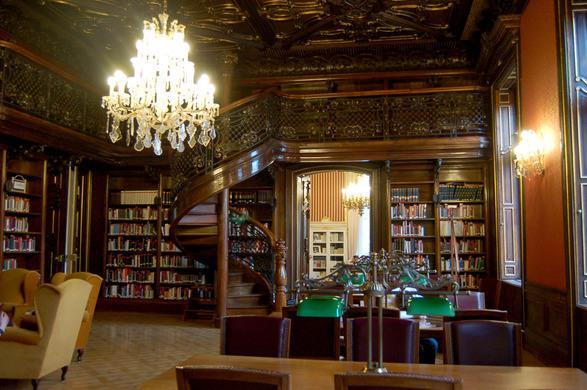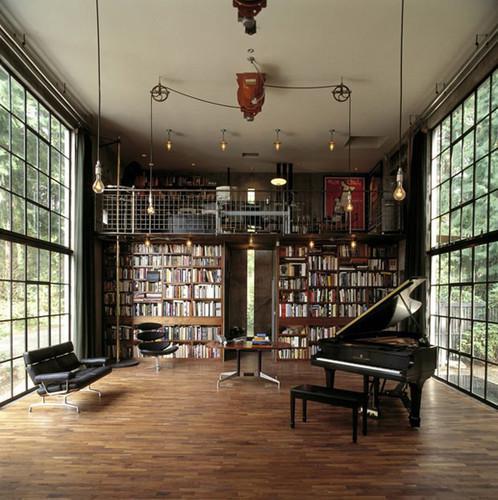The first image is the image on the left, the second image is the image on the right. Assess this claim about the two images: "A room with a bookcase includes a flight of stairs.". Correct or not? Answer yes or no. Yes. 